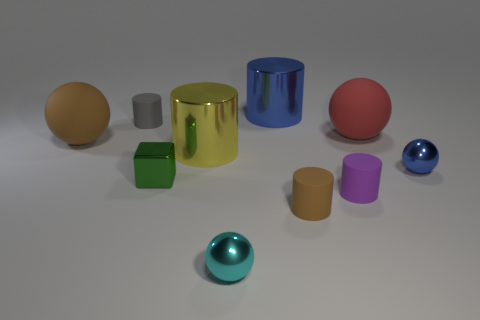Subtract all big yellow metallic cylinders. How many cylinders are left? 4 Subtract all purple balls. Subtract all gray cylinders. How many balls are left? 4 Subtract all balls. How many objects are left? 6 Add 2 small cyan metallic things. How many small cyan metallic things are left? 3 Add 3 red matte things. How many red matte things exist? 4 Subtract 1 blue cylinders. How many objects are left? 9 Subtract all tiny brown things. Subtract all red rubber spheres. How many objects are left? 8 